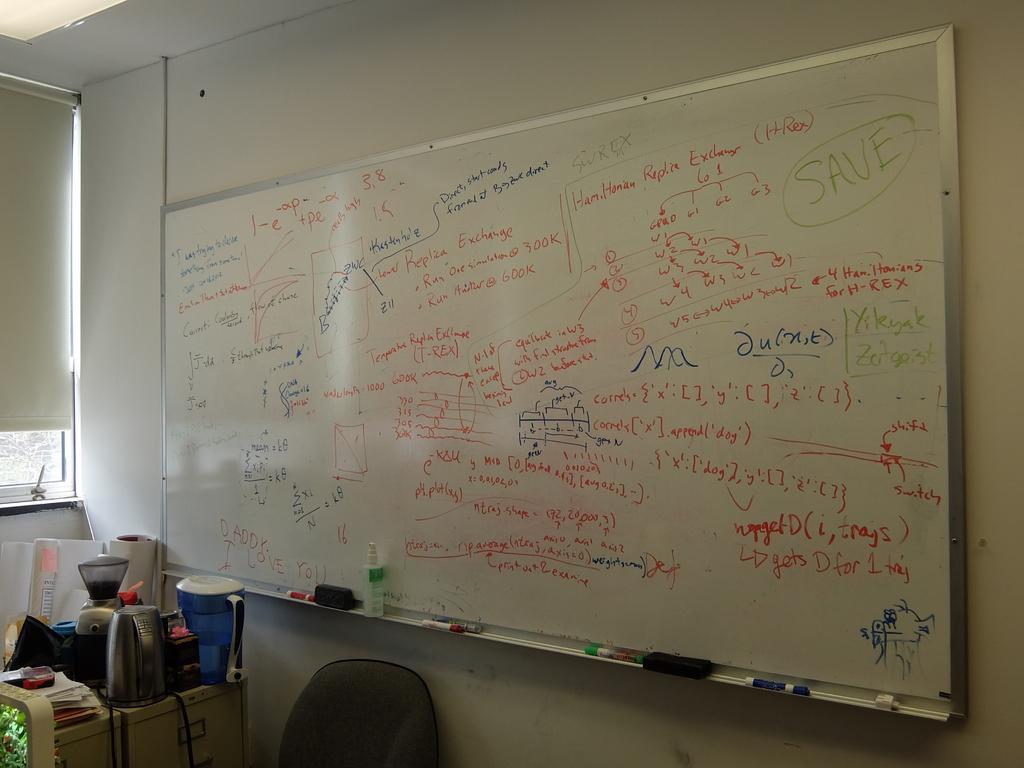How would you summarize this image in a sentence or two? In the image we can see the white board and on the board, we can see the text. Here we can see the markers, water jug and electronic devices. Here we can see the chair, cable wire, pole and the window. 